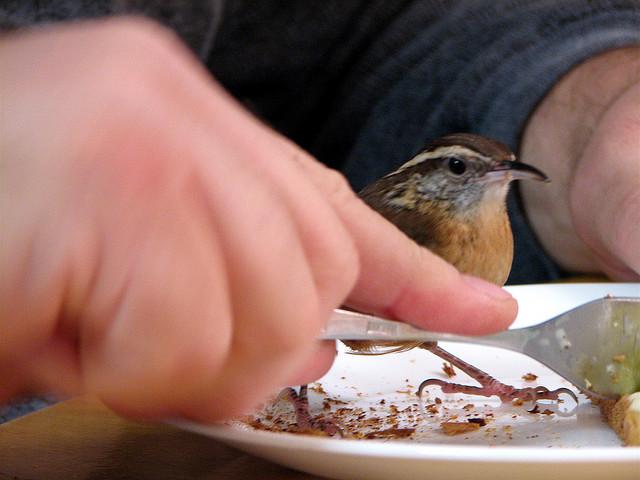What type of bird is photographed?
Be succinct. Sparrow. Would you eat the bird?
Give a very brief answer. No. What are the crumbs on the plate?
Keep it brief. Bread. 